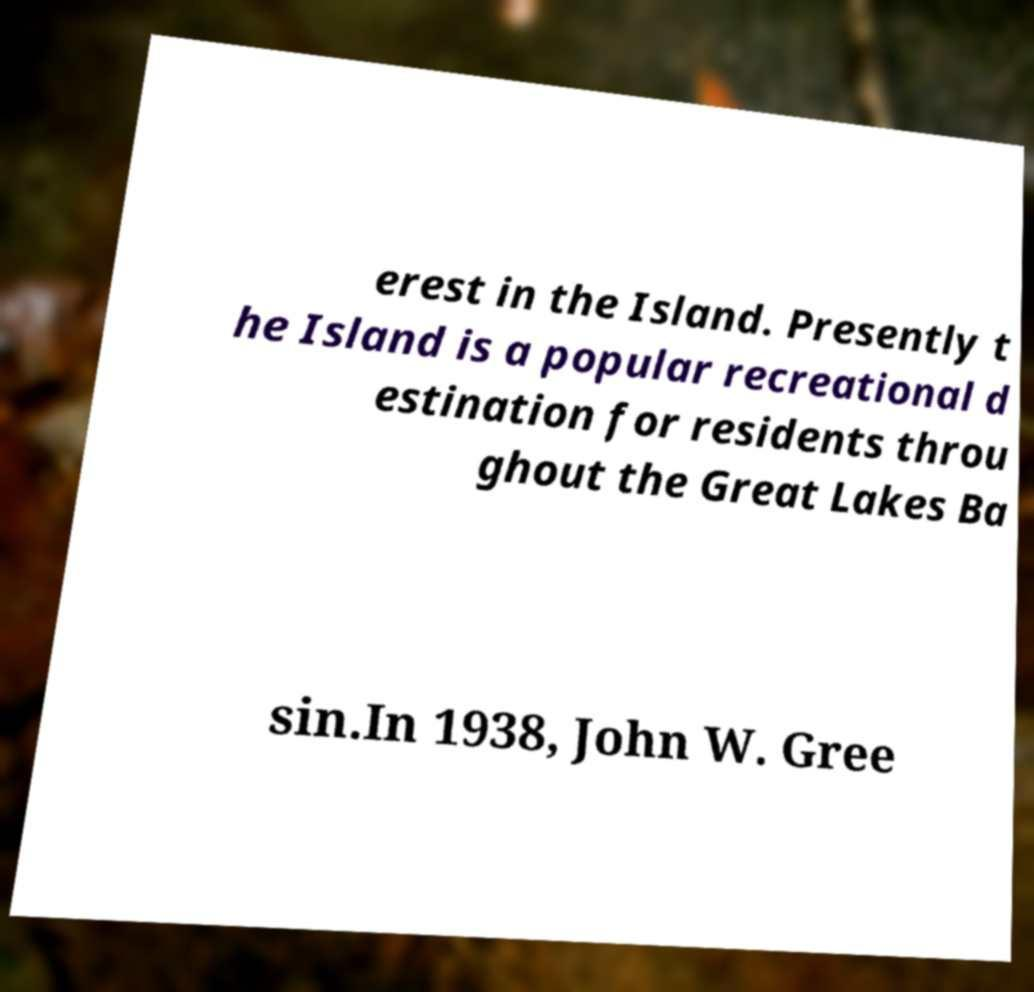For documentation purposes, I need the text within this image transcribed. Could you provide that? erest in the Island. Presently t he Island is a popular recreational d estination for residents throu ghout the Great Lakes Ba sin.In 1938, John W. Gree 